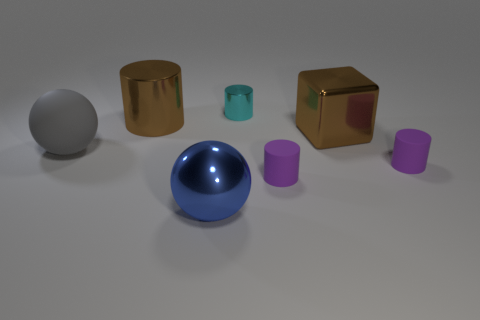Do the big cube and the large metallic cylinder have the same color?
Your answer should be very brief. Yes. What shape is the brown metallic thing that is the same size as the brown metallic cylinder?
Keep it short and to the point. Cube. How big is the cyan cylinder?
Your response must be concise. Small. Does the cylinder that is to the left of the cyan shiny cylinder have the same size as the shiny thing that is right of the cyan cylinder?
Offer a terse response. Yes. What color is the ball on the left side of the large sphere that is in front of the big gray matte thing?
Provide a succinct answer. Gray. There is a brown cylinder that is the same size as the blue object; what is its material?
Your response must be concise. Metal. What number of metallic things are either tiny purple cylinders or blocks?
Offer a terse response. 1. The large metallic thing that is on the left side of the cyan thing and behind the big blue thing is what color?
Give a very brief answer. Brown. There is a big cube; what number of purple objects are right of it?
Give a very brief answer. 1. What is the blue sphere made of?
Give a very brief answer. Metal. 